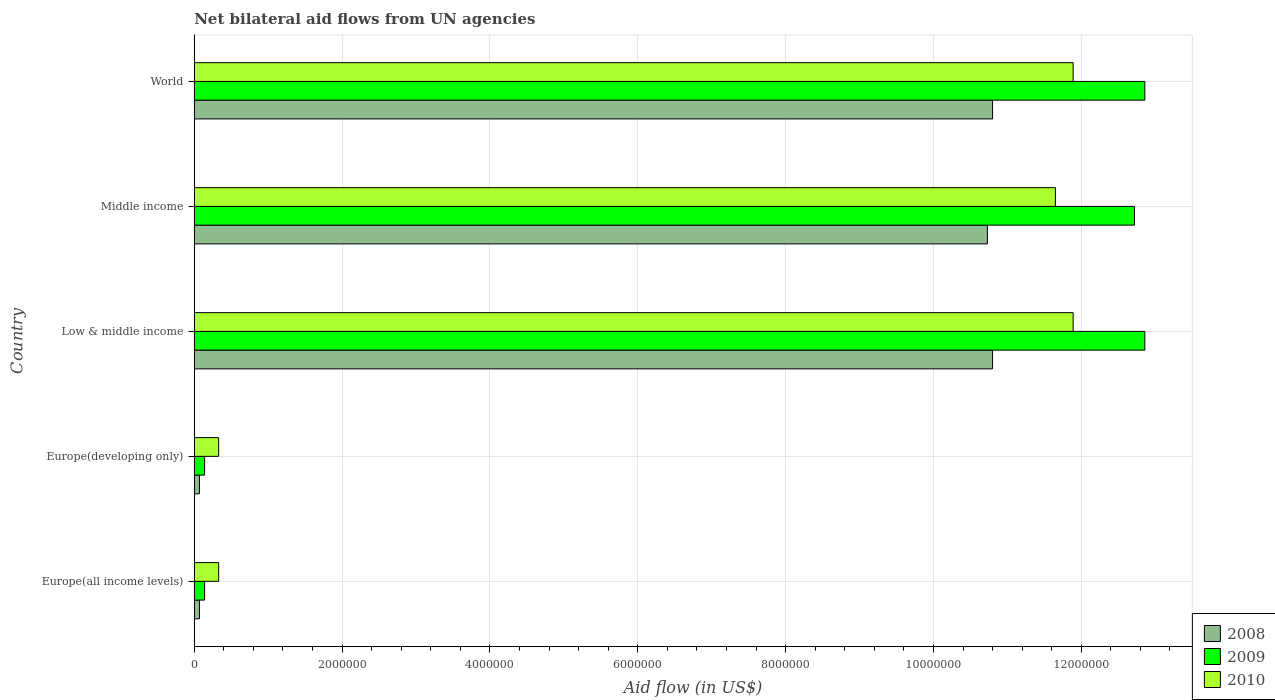How many different coloured bars are there?
Ensure brevity in your answer.  3. How many groups of bars are there?
Offer a very short reply. 5. How many bars are there on the 4th tick from the bottom?
Ensure brevity in your answer.  3. In how many cases, is the number of bars for a given country not equal to the number of legend labels?
Ensure brevity in your answer.  0. Across all countries, what is the maximum net bilateral aid flow in 2009?
Keep it short and to the point. 1.29e+07. In which country was the net bilateral aid flow in 2010 minimum?
Your answer should be compact. Europe(all income levels). What is the total net bilateral aid flow in 2010 in the graph?
Offer a very short reply. 3.61e+07. What is the difference between the net bilateral aid flow in 2010 in Europe(developing only) and that in World?
Provide a short and direct response. -1.16e+07. What is the difference between the net bilateral aid flow in 2010 in Middle income and the net bilateral aid flow in 2008 in World?
Make the answer very short. 8.50e+05. What is the average net bilateral aid flow in 2009 per country?
Keep it short and to the point. 7.74e+06. What is the difference between the net bilateral aid flow in 2008 and net bilateral aid flow in 2009 in Middle income?
Give a very brief answer. -1.99e+06. In how many countries, is the net bilateral aid flow in 2009 greater than 9600000 US$?
Offer a very short reply. 3. What is the ratio of the net bilateral aid flow in 2010 in Europe(all income levels) to that in Europe(developing only)?
Your response must be concise. 1. Is the net bilateral aid flow in 2009 in Europe(all income levels) less than that in World?
Your response must be concise. Yes. Is the difference between the net bilateral aid flow in 2008 in Middle income and World greater than the difference between the net bilateral aid flow in 2009 in Middle income and World?
Your answer should be compact. Yes. What is the difference between the highest and the lowest net bilateral aid flow in 2009?
Offer a terse response. 1.27e+07. Is the sum of the net bilateral aid flow in 2009 in Low & middle income and Middle income greater than the maximum net bilateral aid flow in 2010 across all countries?
Keep it short and to the point. Yes. How many bars are there?
Your answer should be very brief. 15. Are all the bars in the graph horizontal?
Make the answer very short. Yes. How many countries are there in the graph?
Provide a succinct answer. 5. Does the graph contain grids?
Your response must be concise. Yes. Where does the legend appear in the graph?
Offer a very short reply. Bottom right. How many legend labels are there?
Keep it short and to the point. 3. What is the title of the graph?
Keep it short and to the point. Net bilateral aid flows from UN agencies. Does "1983" appear as one of the legend labels in the graph?
Keep it short and to the point. No. What is the label or title of the X-axis?
Your response must be concise. Aid flow (in US$). What is the label or title of the Y-axis?
Your answer should be very brief. Country. What is the Aid flow (in US$) of 2009 in Europe(developing only)?
Make the answer very short. 1.40e+05. What is the Aid flow (in US$) in 2010 in Europe(developing only)?
Provide a short and direct response. 3.30e+05. What is the Aid flow (in US$) of 2008 in Low & middle income?
Your answer should be compact. 1.08e+07. What is the Aid flow (in US$) of 2009 in Low & middle income?
Provide a short and direct response. 1.29e+07. What is the Aid flow (in US$) of 2010 in Low & middle income?
Offer a very short reply. 1.19e+07. What is the Aid flow (in US$) of 2008 in Middle income?
Provide a short and direct response. 1.07e+07. What is the Aid flow (in US$) of 2009 in Middle income?
Ensure brevity in your answer.  1.27e+07. What is the Aid flow (in US$) in 2010 in Middle income?
Give a very brief answer. 1.16e+07. What is the Aid flow (in US$) in 2008 in World?
Provide a succinct answer. 1.08e+07. What is the Aid flow (in US$) in 2009 in World?
Your response must be concise. 1.29e+07. What is the Aid flow (in US$) of 2010 in World?
Make the answer very short. 1.19e+07. Across all countries, what is the maximum Aid flow (in US$) in 2008?
Keep it short and to the point. 1.08e+07. Across all countries, what is the maximum Aid flow (in US$) of 2009?
Offer a terse response. 1.29e+07. Across all countries, what is the maximum Aid flow (in US$) of 2010?
Provide a succinct answer. 1.19e+07. Across all countries, what is the minimum Aid flow (in US$) in 2008?
Ensure brevity in your answer.  7.00e+04. What is the total Aid flow (in US$) in 2008 in the graph?
Provide a succinct answer. 3.25e+07. What is the total Aid flow (in US$) in 2009 in the graph?
Keep it short and to the point. 3.87e+07. What is the total Aid flow (in US$) of 2010 in the graph?
Keep it short and to the point. 3.61e+07. What is the difference between the Aid flow (in US$) in 2008 in Europe(all income levels) and that in Europe(developing only)?
Ensure brevity in your answer.  0. What is the difference between the Aid flow (in US$) in 2008 in Europe(all income levels) and that in Low & middle income?
Provide a succinct answer. -1.07e+07. What is the difference between the Aid flow (in US$) in 2009 in Europe(all income levels) and that in Low & middle income?
Provide a short and direct response. -1.27e+07. What is the difference between the Aid flow (in US$) of 2010 in Europe(all income levels) and that in Low & middle income?
Make the answer very short. -1.16e+07. What is the difference between the Aid flow (in US$) in 2008 in Europe(all income levels) and that in Middle income?
Offer a terse response. -1.07e+07. What is the difference between the Aid flow (in US$) of 2009 in Europe(all income levels) and that in Middle income?
Make the answer very short. -1.26e+07. What is the difference between the Aid flow (in US$) of 2010 in Europe(all income levels) and that in Middle income?
Provide a short and direct response. -1.13e+07. What is the difference between the Aid flow (in US$) of 2008 in Europe(all income levels) and that in World?
Ensure brevity in your answer.  -1.07e+07. What is the difference between the Aid flow (in US$) in 2009 in Europe(all income levels) and that in World?
Offer a terse response. -1.27e+07. What is the difference between the Aid flow (in US$) of 2010 in Europe(all income levels) and that in World?
Your response must be concise. -1.16e+07. What is the difference between the Aid flow (in US$) of 2008 in Europe(developing only) and that in Low & middle income?
Your response must be concise. -1.07e+07. What is the difference between the Aid flow (in US$) of 2009 in Europe(developing only) and that in Low & middle income?
Keep it short and to the point. -1.27e+07. What is the difference between the Aid flow (in US$) in 2010 in Europe(developing only) and that in Low & middle income?
Make the answer very short. -1.16e+07. What is the difference between the Aid flow (in US$) in 2008 in Europe(developing only) and that in Middle income?
Your answer should be compact. -1.07e+07. What is the difference between the Aid flow (in US$) in 2009 in Europe(developing only) and that in Middle income?
Provide a short and direct response. -1.26e+07. What is the difference between the Aid flow (in US$) in 2010 in Europe(developing only) and that in Middle income?
Make the answer very short. -1.13e+07. What is the difference between the Aid flow (in US$) of 2008 in Europe(developing only) and that in World?
Keep it short and to the point. -1.07e+07. What is the difference between the Aid flow (in US$) in 2009 in Europe(developing only) and that in World?
Make the answer very short. -1.27e+07. What is the difference between the Aid flow (in US$) in 2010 in Europe(developing only) and that in World?
Provide a short and direct response. -1.16e+07. What is the difference between the Aid flow (in US$) in 2008 in Low & middle income and that in Middle income?
Your response must be concise. 7.00e+04. What is the difference between the Aid flow (in US$) in 2009 in Low & middle income and that in Middle income?
Your answer should be compact. 1.40e+05. What is the difference between the Aid flow (in US$) of 2010 in Low & middle income and that in Middle income?
Your answer should be compact. 2.40e+05. What is the difference between the Aid flow (in US$) in 2009 in Middle income and that in World?
Offer a terse response. -1.40e+05. What is the difference between the Aid flow (in US$) of 2010 in Middle income and that in World?
Your answer should be very brief. -2.40e+05. What is the difference between the Aid flow (in US$) of 2008 in Europe(all income levels) and the Aid flow (in US$) of 2010 in Europe(developing only)?
Provide a short and direct response. -2.60e+05. What is the difference between the Aid flow (in US$) in 2008 in Europe(all income levels) and the Aid flow (in US$) in 2009 in Low & middle income?
Ensure brevity in your answer.  -1.28e+07. What is the difference between the Aid flow (in US$) of 2008 in Europe(all income levels) and the Aid flow (in US$) of 2010 in Low & middle income?
Make the answer very short. -1.18e+07. What is the difference between the Aid flow (in US$) in 2009 in Europe(all income levels) and the Aid flow (in US$) in 2010 in Low & middle income?
Offer a very short reply. -1.18e+07. What is the difference between the Aid flow (in US$) of 2008 in Europe(all income levels) and the Aid flow (in US$) of 2009 in Middle income?
Offer a very short reply. -1.26e+07. What is the difference between the Aid flow (in US$) of 2008 in Europe(all income levels) and the Aid flow (in US$) of 2010 in Middle income?
Your answer should be compact. -1.16e+07. What is the difference between the Aid flow (in US$) in 2009 in Europe(all income levels) and the Aid flow (in US$) in 2010 in Middle income?
Your answer should be compact. -1.15e+07. What is the difference between the Aid flow (in US$) of 2008 in Europe(all income levels) and the Aid flow (in US$) of 2009 in World?
Provide a short and direct response. -1.28e+07. What is the difference between the Aid flow (in US$) in 2008 in Europe(all income levels) and the Aid flow (in US$) in 2010 in World?
Keep it short and to the point. -1.18e+07. What is the difference between the Aid flow (in US$) in 2009 in Europe(all income levels) and the Aid flow (in US$) in 2010 in World?
Make the answer very short. -1.18e+07. What is the difference between the Aid flow (in US$) of 2008 in Europe(developing only) and the Aid flow (in US$) of 2009 in Low & middle income?
Your answer should be compact. -1.28e+07. What is the difference between the Aid flow (in US$) of 2008 in Europe(developing only) and the Aid flow (in US$) of 2010 in Low & middle income?
Ensure brevity in your answer.  -1.18e+07. What is the difference between the Aid flow (in US$) of 2009 in Europe(developing only) and the Aid flow (in US$) of 2010 in Low & middle income?
Offer a very short reply. -1.18e+07. What is the difference between the Aid flow (in US$) of 2008 in Europe(developing only) and the Aid flow (in US$) of 2009 in Middle income?
Keep it short and to the point. -1.26e+07. What is the difference between the Aid flow (in US$) in 2008 in Europe(developing only) and the Aid flow (in US$) in 2010 in Middle income?
Keep it short and to the point. -1.16e+07. What is the difference between the Aid flow (in US$) of 2009 in Europe(developing only) and the Aid flow (in US$) of 2010 in Middle income?
Provide a succinct answer. -1.15e+07. What is the difference between the Aid flow (in US$) in 2008 in Europe(developing only) and the Aid flow (in US$) in 2009 in World?
Offer a terse response. -1.28e+07. What is the difference between the Aid flow (in US$) in 2008 in Europe(developing only) and the Aid flow (in US$) in 2010 in World?
Your answer should be compact. -1.18e+07. What is the difference between the Aid flow (in US$) in 2009 in Europe(developing only) and the Aid flow (in US$) in 2010 in World?
Offer a terse response. -1.18e+07. What is the difference between the Aid flow (in US$) of 2008 in Low & middle income and the Aid flow (in US$) of 2009 in Middle income?
Offer a terse response. -1.92e+06. What is the difference between the Aid flow (in US$) of 2008 in Low & middle income and the Aid flow (in US$) of 2010 in Middle income?
Keep it short and to the point. -8.50e+05. What is the difference between the Aid flow (in US$) of 2009 in Low & middle income and the Aid flow (in US$) of 2010 in Middle income?
Make the answer very short. 1.21e+06. What is the difference between the Aid flow (in US$) in 2008 in Low & middle income and the Aid flow (in US$) in 2009 in World?
Your answer should be very brief. -2.06e+06. What is the difference between the Aid flow (in US$) in 2008 in Low & middle income and the Aid flow (in US$) in 2010 in World?
Provide a succinct answer. -1.09e+06. What is the difference between the Aid flow (in US$) of 2009 in Low & middle income and the Aid flow (in US$) of 2010 in World?
Provide a succinct answer. 9.70e+05. What is the difference between the Aid flow (in US$) of 2008 in Middle income and the Aid flow (in US$) of 2009 in World?
Ensure brevity in your answer.  -2.13e+06. What is the difference between the Aid flow (in US$) of 2008 in Middle income and the Aid flow (in US$) of 2010 in World?
Your response must be concise. -1.16e+06. What is the difference between the Aid flow (in US$) of 2009 in Middle income and the Aid flow (in US$) of 2010 in World?
Ensure brevity in your answer.  8.30e+05. What is the average Aid flow (in US$) in 2008 per country?
Offer a very short reply. 6.49e+06. What is the average Aid flow (in US$) of 2009 per country?
Keep it short and to the point. 7.74e+06. What is the average Aid flow (in US$) in 2010 per country?
Your response must be concise. 7.22e+06. What is the difference between the Aid flow (in US$) of 2008 and Aid flow (in US$) of 2010 in Europe(all income levels)?
Your answer should be compact. -2.60e+05. What is the difference between the Aid flow (in US$) in 2008 and Aid flow (in US$) in 2009 in Europe(developing only)?
Keep it short and to the point. -7.00e+04. What is the difference between the Aid flow (in US$) of 2008 and Aid flow (in US$) of 2010 in Europe(developing only)?
Keep it short and to the point. -2.60e+05. What is the difference between the Aid flow (in US$) of 2009 and Aid flow (in US$) of 2010 in Europe(developing only)?
Provide a succinct answer. -1.90e+05. What is the difference between the Aid flow (in US$) in 2008 and Aid flow (in US$) in 2009 in Low & middle income?
Your answer should be very brief. -2.06e+06. What is the difference between the Aid flow (in US$) in 2008 and Aid flow (in US$) in 2010 in Low & middle income?
Your response must be concise. -1.09e+06. What is the difference between the Aid flow (in US$) of 2009 and Aid flow (in US$) of 2010 in Low & middle income?
Offer a very short reply. 9.70e+05. What is the difference between the Aid flow (in US$) of 2008 and Aid flow (in US$) of 2009 in Middle income?
Your answer should be very brief. -1.99e+06. What is the difference between the Aid flow (in US$) in 2008 and Aid flow (in US$) in 2010 in Middle income?
Your response must be concise. -9.20e+05. What is the difference between the Aid flow (in US$) of 2009 and Aid flow (in US$) of 2010 in Middle income?
Keep it short and to the point. 1.07e+06. What is the difference between the Aid flow (in US$) in 2008 and Aid flow (in US$) in 2009 in World?
Provide a succinct answer. -2.06e+06. What is the difference between the Aid flow (in US$) in 2008 and Aid flow (in US$) in 2010 in World?
Make the answer very short. -1.09e+06. What is the difference between the Aid flow (in US$) in 2009 and Aid flow (in US$) in 2010 in World?
Provide a succinct answer. 9.70e+05. What is the ratio of the Aid flow (in US$) in 2008 in Europe(all income levels) to that in Europe(developing only)?
Your answer should be very brief. 1. What is the ratio of the Aid flow (in US$) in 2009 in Europe(all income levels) to that in Europe(developing only)?
Give a very brief answer. 1. What is the ratio of the Aid flow (in US$) in 2010 in Europe(all income levels) to that in Europe(developing only)?
Give a very brief answer. 1. What is the ratio of the Aid flow (in US$) of 2008 in Europe(all income levels) to that in Low & middle income?
Your response must be concise. 0.01. What is the ratio of the Aid flow (in US$) of 2009 in Europe(all income levels) to that in Low & middle income?
Give a very brief answer. 0.01. What is the ratio of the Aid flow (in US$) in 2010 in Europe(all income levels) to that in Low & middle income?
Offer a very short reply. 0.03. What is the ratio of the Aid flow (in US$) of 2008 in Europe(all income levels) to that in Middle income?
Offer a terse response. 0.01. What is the ratio of the Aid flow (in US$) in 2009 in Europe(all income levels) to that in Middle income?
Make the answer very short. 0.01. What is the ratio of the Aid flow (in US$) of 2010 in Europe(all income levels) to that in Middle income?
Your answer should be compact. 0.03. What is the ratio of the Aid flow (in US$) in 2008 in Europe(all income levels) to that in World?
Offer a very short reply. 0.01. What is the ratio of the Aid flow (in US$) of 2009 in Europe(all income levels) to that in World?
Provide a short and direct response. 0.01. What is the ratio of the Aid flow (in US$) of 2010 in Europe(all income levels) to that in World?
Offer a very short reply. 0.03. What is the ratio of the Aid flow (in US$) in 2008 in Europe(developing only) to that in Low & middle income?
Make the answer very short. 0.01. What is the ratio of the Aid flow (in US$) of 2009 in Europe(developing only) to that in Low & middle income?
Your response must be concise. 0.01. What is the ratio of the Aid flow (in US$) in 2010 in Europe(developing only) to that in Low & middle income?
Keep it short and to the point. 0.03. What is the ratio of the Aid flow (in US$) of 2008 in Europe(developing only) to that in Middle income?
Provide a short and direct response. 0.01. What is the ratio of the Aid flow (in US$) of 2009 in Europe(developing only) to that in Middle income?
Offer a very short reply. 0.01. What is the ratio of the Aid flow (in US$) of 2010 in Europe(developing only) to that in Middle income?
Ensure brevity in your answer.  0.03. What is the ratio of the Aid flow (in US$) of 2008 in Europe(developing only) to that in World?
Provide a succinct answer. 0.01. What is the ratio of the Aid flow (in US$) in 2009 in Europe(developing only) to that in World?
Provide a short and direct response. 0.01. What is the ratio of the Aid flow (in US$) of 2010 in Europe(developing only) to that in World?
Give a very brief answer. 0.03. What is the ratio of the Aid flow (in US$) in 2010 in Low & middle income to that in Middle income?
Provide a short and direct response. 1.02. What is the ratio of the Aid flow (in US$) in 2010 in Low & middle income to that in World?
Make the answer very short. 1. What is the ratio of the Aid flow (in US$) of 2008 in Middle income to that in World?
Provide a succinct answer. 0.99. What is the ratio of the Aid flow (in US$) in 2009 in Middle income to that in World?
Ensure brevity in your answer.  0.99. What is the ratio of the Aid flow (in US$) of 2010 in Middle income to that in World?
Ensure brevity in your answer.  0.98. What is the difference between the highest and the second highest Aid flow (in US$) of 2010?
Offer a terse response. 0. What is the difference between the highest and the lowest Aid flow (in US$) of 2008?
Provide a succinct answer. 1.07e+07. What is the difference between the highest and the lowest Aid flow (in US$) in 2009?
Ensure brevity in your answer.  1.27e+07. What is the difference between the highest and the lowest Aid flow (in US$) of 2010?
Provide a succinct answer. 1.16e+07. 